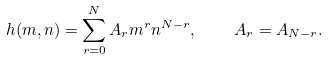<formula> <loc_0><loc_0><loc_500><loc_500>h ( m , n ) = \sum _ { r = 0 } ^ { N } A _ { r } m ^ { r } n ^ { N - r } , \quad A _ { r } = A _ { N - r } .</formula> 